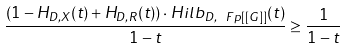<formula> <loc_0><loc_0><loc_500><loc_500>\frac { ( 1 - H _ { D , X } ( t ) + H _ { D , { R } } ( t ) ) \cdot H i l b _ { D , \ F p [ [ G ] ] } ( t ) } { 1 - t } \geq \frac { 1 } { 1 - t }</formula> 